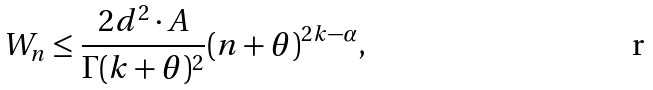<formula> <loc_0><loc_0><loc_500><loc_500>W _ { n } & \leq \frac { 2 d ^ { 2 } \cdot A } { \Gamma ( k + \theta ) ^ { 2 } } ( n + \theta ) ^ { 2 k - \alpha } ,</formula> 